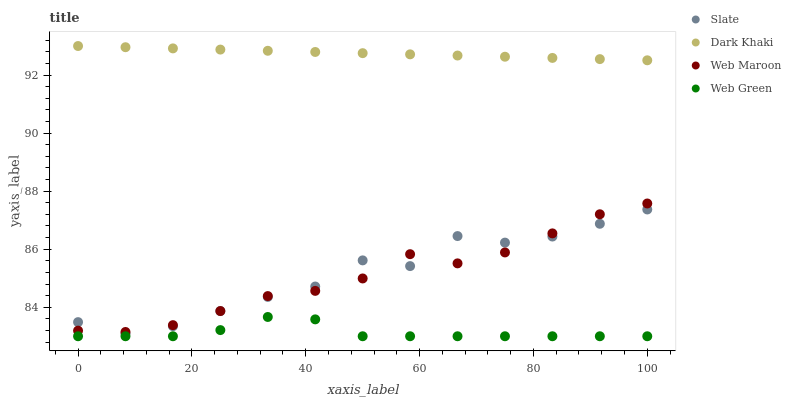Does Web Green have the minimum area under the curve?
Answer yes or no. Yes. Does Dark Khaki have the maximum area under the curve?
Answer yes or no. Yes. Does Slate have the minimum area under the curve?
Answer yes or no. No. Does Slate have the maximum area under the curve?
Answer yes or no. No. Is Dark Khaki the smoothest?
Answer yes or no. Yes. Is Slate the roughest?
Answer yes or no. Yes. Is Web Maroon the smoothest?
Answer yes or no. No. Is Web Maroon the roughest?
Answer yes or no. No. Does Web Green have the lowest value?
Answer yes or no. Yes. Does Slate have the lowest value?
Answer yes or no. No. Does Dark Khaki have the highest value?
Answer yes or no. Yes. Does Slate have the highest value?
Answer yes or no. No. Is Web Green less than Dark Khaki?
Answer yes or no. Yes. Is Slate greater than Web Green?
Answer yes or no. Yes. Does Web Maroon intersect Slate?
Answer yes or no. Yes. Is Web Maroon less than Slate?
Answer yes or no. No. Is Web Maroon greater than Slate?
Answer yes or no. No. Does Web Green intersect Dark Khaki?
Answer yes or no. No. 